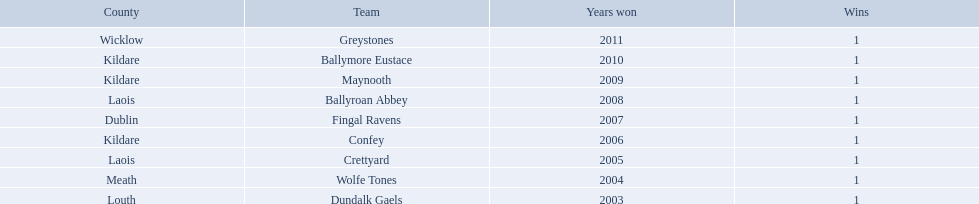Where is ballymore eustace from? Kildare. What teams other than ballymore eustace is from kildare? Maynooth, Confey. Between maynooth and confey, which won in 2009? Maynooth. 